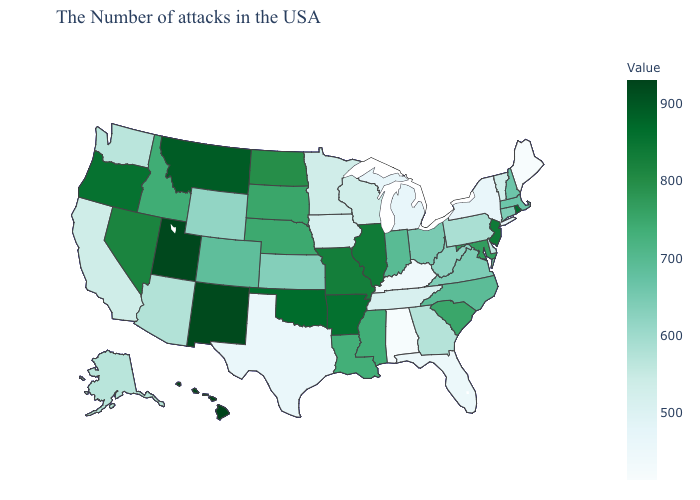Which states have the lowest value in the USA?
Short answer required. Maine. Does the map have missing data?
Give a very brief answer. No. Does Minnesota have a lower value than Hawaii?
Quick response, please. Yes. Does Hawaii have the highest value in the West?
Write a very short answer. Yes. Among the states that border Ohio , which have the lowest value?
Quick response, please. Kentucky. Among the states that border Wisconsin , which have the lowest value?
Concise answer only. Michigan. Among the states that border Ohio , does Indiana have the highest value?
Quick response, please. Yes. Does Hawaii have the highest value in the USA?
Short answer required. Yes. Among the states that border Wyoming , does Utah have the highest value?
Short answer required. Yes. Which states hav the highest value in the MidWest?
Quick response, please. Illinois. 